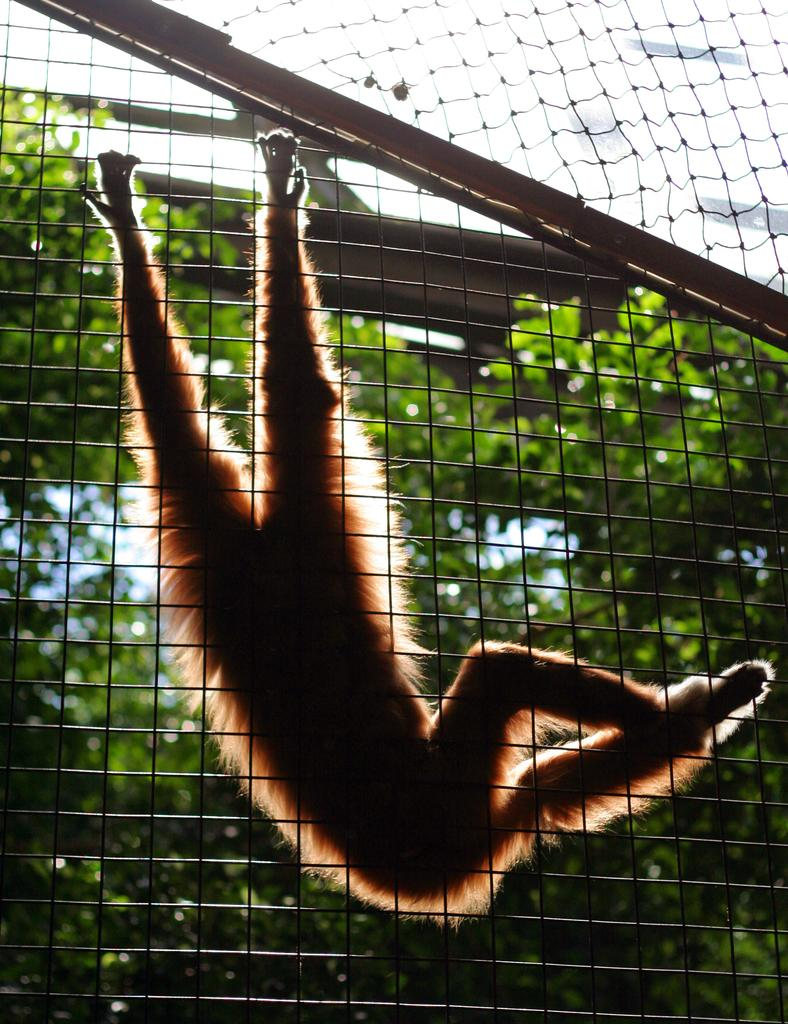What animal is present in the image? There is a monkey in the image. What is the color of the monkey? The monkey has a brown color. What is the monkey doing in the image? The monkey is holding the fence. What can be seen in the background of the image? There are trees visible behind the monkey. What type of mint is growing on the trail in the image? There is no trail or mint present in the image; it features a monkey holding a fence with trees in the background. 